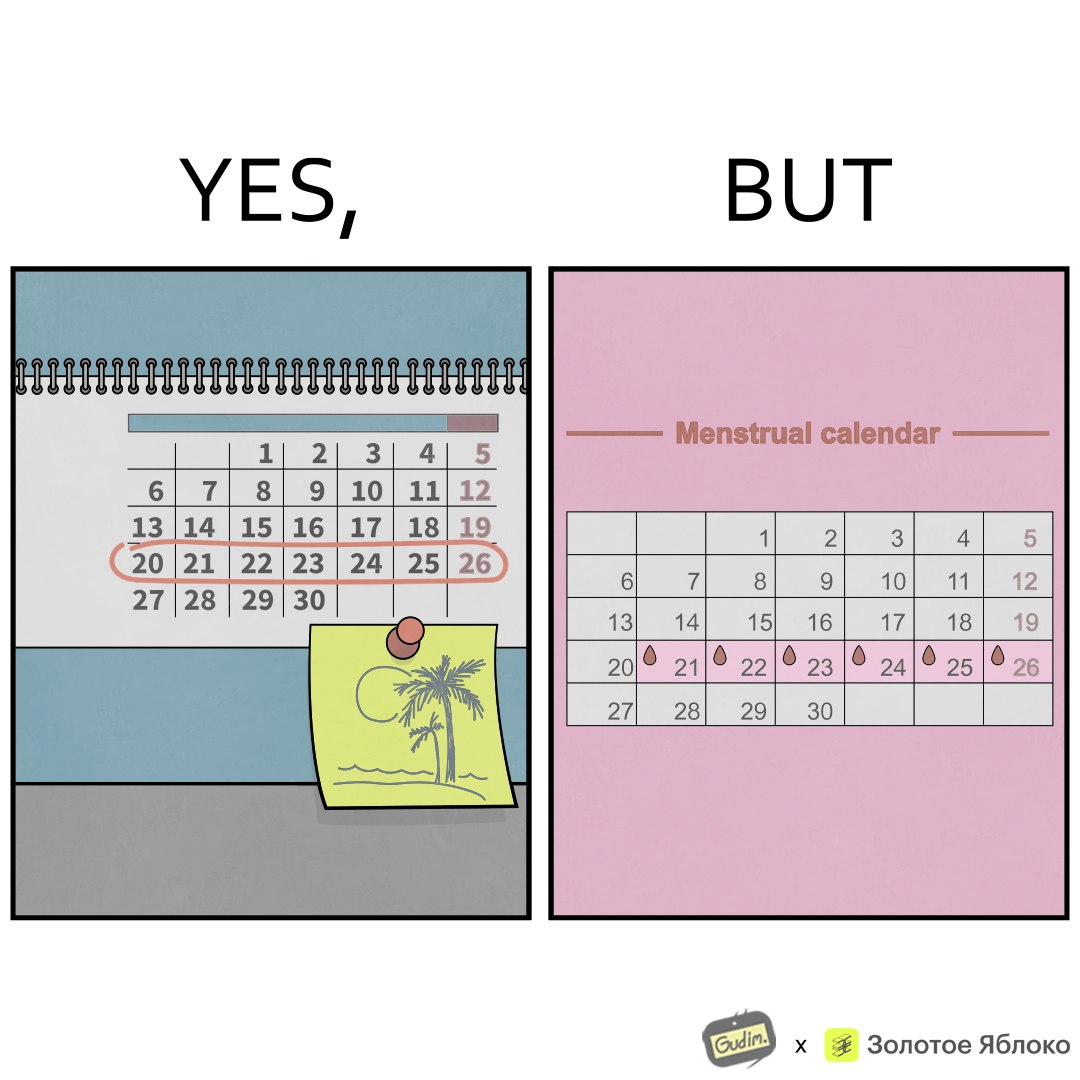Is this image satirical or non-satirical? Yes, this image is satirical. 